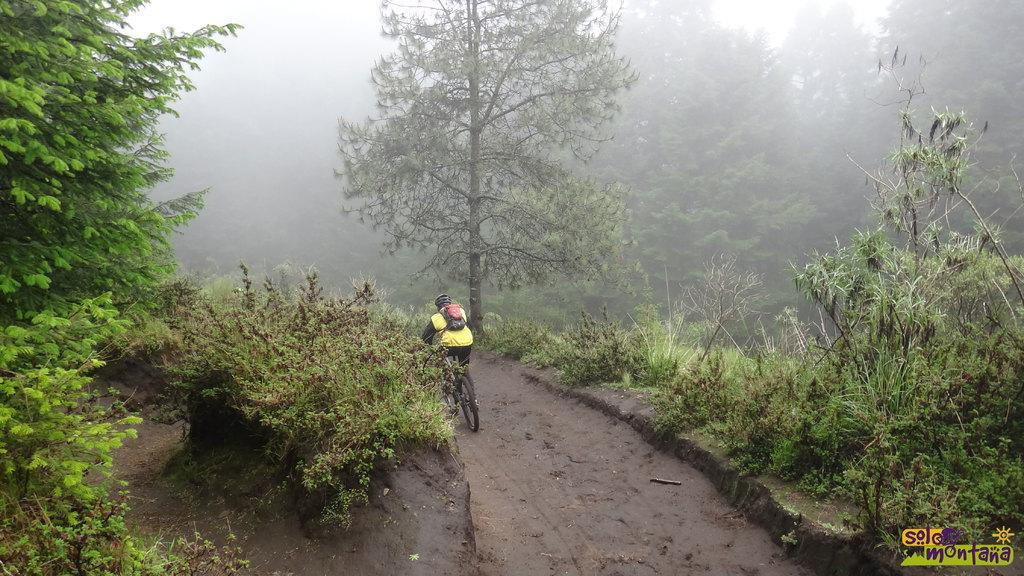What is the main subject of the image? There is a person in the center of the image. What is the person wearing? The person is wearing a coat and a helmet. What is the person carrying? The person is carrying a bag. What is the person doing in the image? The person is riding a bicycle. What can be seen in the background of the image? There are trees in the background of the image. What is visible at the bottom of the image? There is ground visible at the bottom of the image. Where is the light switch located in the image? There is no light switch present in the image; it features a person riding a bicycle. What type of map is the person holding in the image? There is no map present in the image; the person is carrying a bag. 